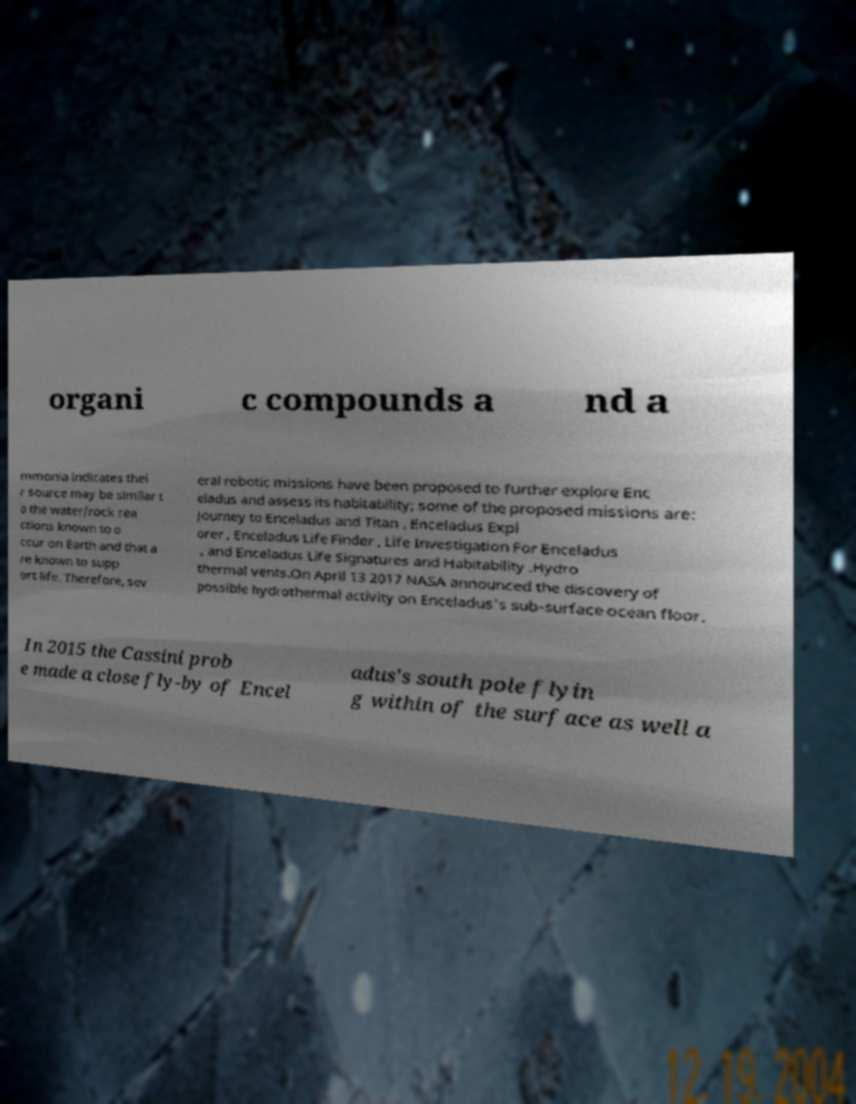For documentation purposes, I need the text within this image transcribed. Could you provide that? organi c compounds a nd a mmonia indicates thei r source may be similar t o the water/rock rea ctions known to o ccur on Earth and that a re known to supp ort life. Therefore, sev eral robotic missions have been proposed to further explore Enc eladus and assess its habitability; some of the proposed missions are: Journey to Enceladus and Titan , Enceladus Expl orer , Enceladus Life Finder , Life Investigation For Enceladus , and Enceladus Life Signatures and Habitability .Hydro thermal vents.On April 13 2017 NASA announced the discovery of possible hydrothermal activity on Enceladus's sub-surface ocean floor. In 2015 the Cassini prob e made a close fly-by of Encel adus's south pole flyin g within of the surface as well a 